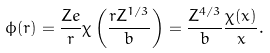<formula> <loc_0><loc_0><loc_500><loc_500>\phi ( r ) = { \frac { Z e } { r } } \chi \left ( { \frac { r Z ^ { 1 / 3 } } { b } } \right ) = { \frac { Z ^ { 4 / 3 } } { b } } { \frac { \chi ( x ) } { x } } .</formula> 